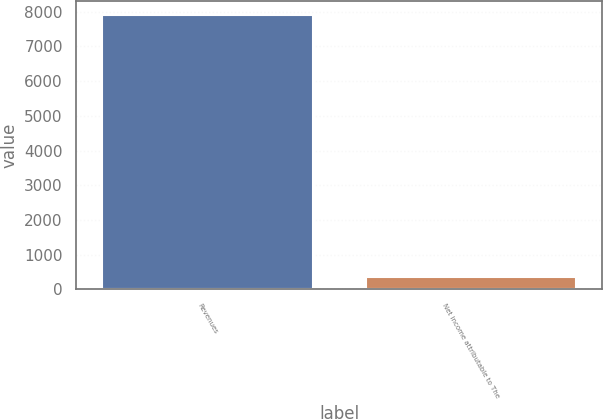<chart> <loc_0><loc_0><loc_500><loc_500><bar_chart><fcel>Revenues<fcel>Net income attributable to The<nl><fcel>7906<fcel>356<nl></chart> 